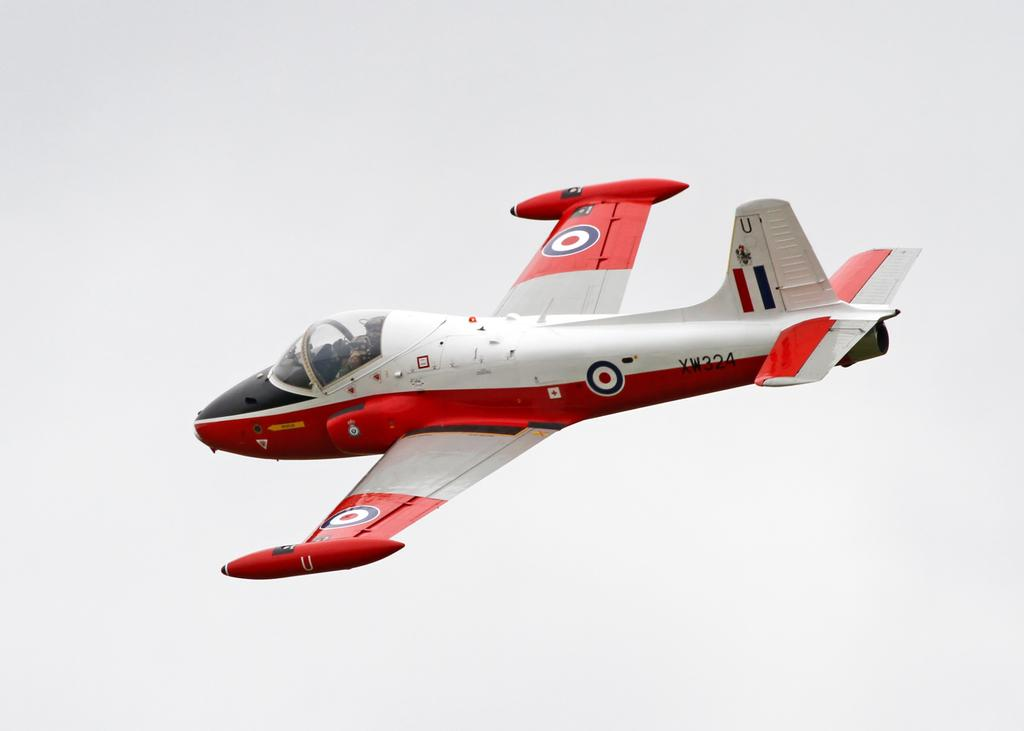<image>
Share a concise interpretation of the image provided. the letters X and W are on the red and white plane 